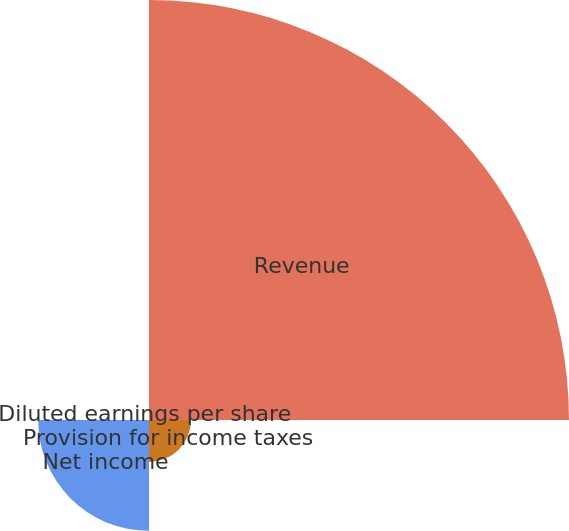Convert chart to OTSL. <chart><loc_0><loc_0><loc_500><loc_500><pie_chart><fcel>Revenue<fcel>Provision for income taxes<fcel>Net income<fcel>Diluted earnings per share<nl><fcel>73.31%<fcel>7.33%<fcel>19.35%<fcel>0.0%<nl></chart> 